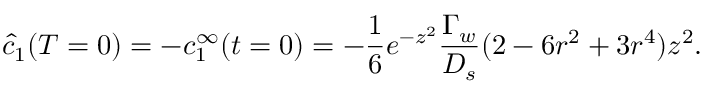Convert formula to latex. <formula><loc_0><loc_0><loc_500><loc_500>\hat { c } _ { 1 } ( T = 0 ) = - c _ { 1 } ^ { \infty } ( t = 0 ) = - \frac { 1 } { 6 } e ^ { - z ^ { 2 } } \frac { \Gamma _ { w } } { D _ { s } } ( 2 - 6 r ^ { 2 } + 3 r ^ { 4 } ) z ^ { 2 } .</formula> 